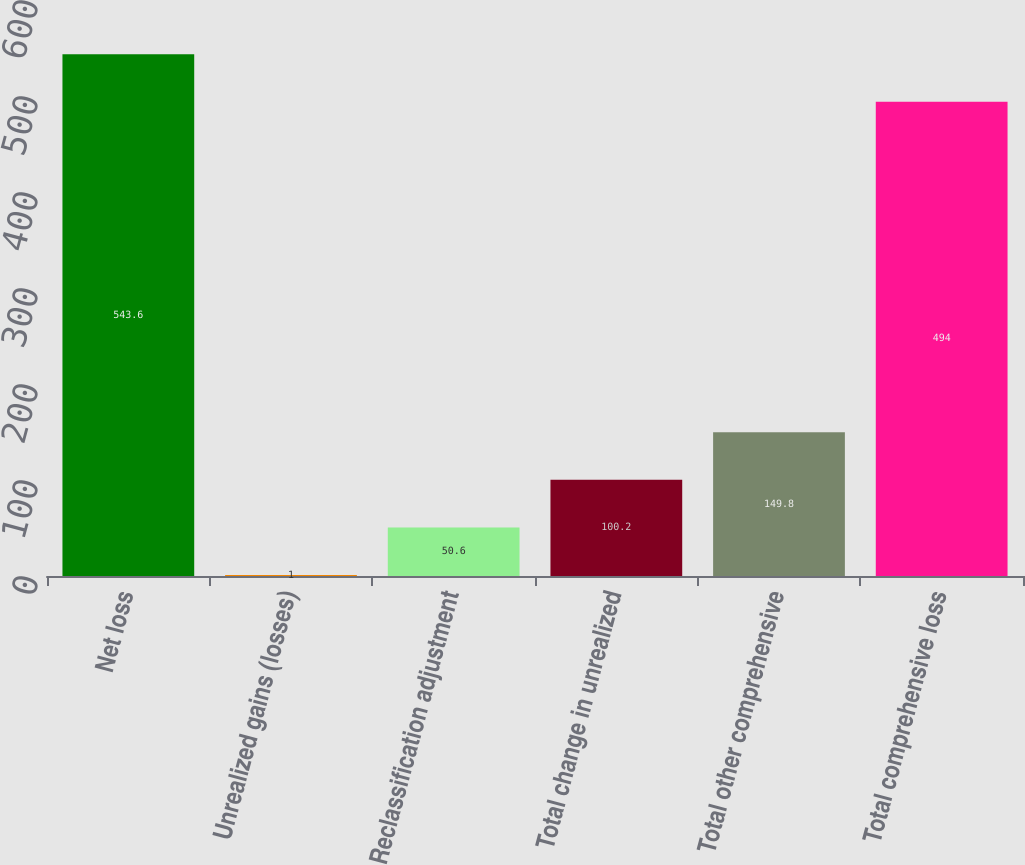Convert chart to OTSL. <chart><loc_0><loc_0><loc_500><loc_500><bar_chart><fcel>Net loss<fcel>Unrealized gains (losses)<fcel>Reclassification adjustment<fcel>Total change in unrealized<fcel>Total other comprehensive<fcel>Total comprehensive loss<nl><fcel>543.6<fcel>1<fcel>50.6<fcel>100.2<fcel>149.8<fcel>494<nl></chart> 